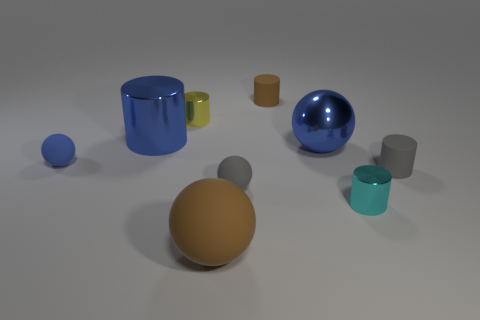There is a gray object that is the same shape as the small blue thing; what is its material?
Make the answer very short. Rubber. What color is the large shiny thing that is behind the large blue metal sphere?
Give a very brief answer. Blue. Is the tiny brown object made of the same material as the brown object to the left of the tiny brown rubber thing?
Make the answer very short. Yes. What material is the yellow cylinder?
Ensure brevity in your answer.  Metal. What is the shape of the large object that is made of the same material as the tiny brown object?
Offer a terse response. Sphere. What number of other things are there of the same shape as the small blue thing?
Your answer should be very brief. 3. What number of rubber objects are behind the small yellow cylinder?
Ensure brevity in your answer.  1. Do the matte cylinder that is right of the big blue shiny ball and the brown object that is behind the small gray rubber sphere have the same size?
Keep it short and to the point. Yes. How many other things are the same size as the yellow shiny object?
Offer a terse response. 5. The tiny cylinder that is in front of the tiny rubber cylinder that is to the right of the tiny matte object behind the big metallic ball is made of what material?
Make the answer very short. Metal. 